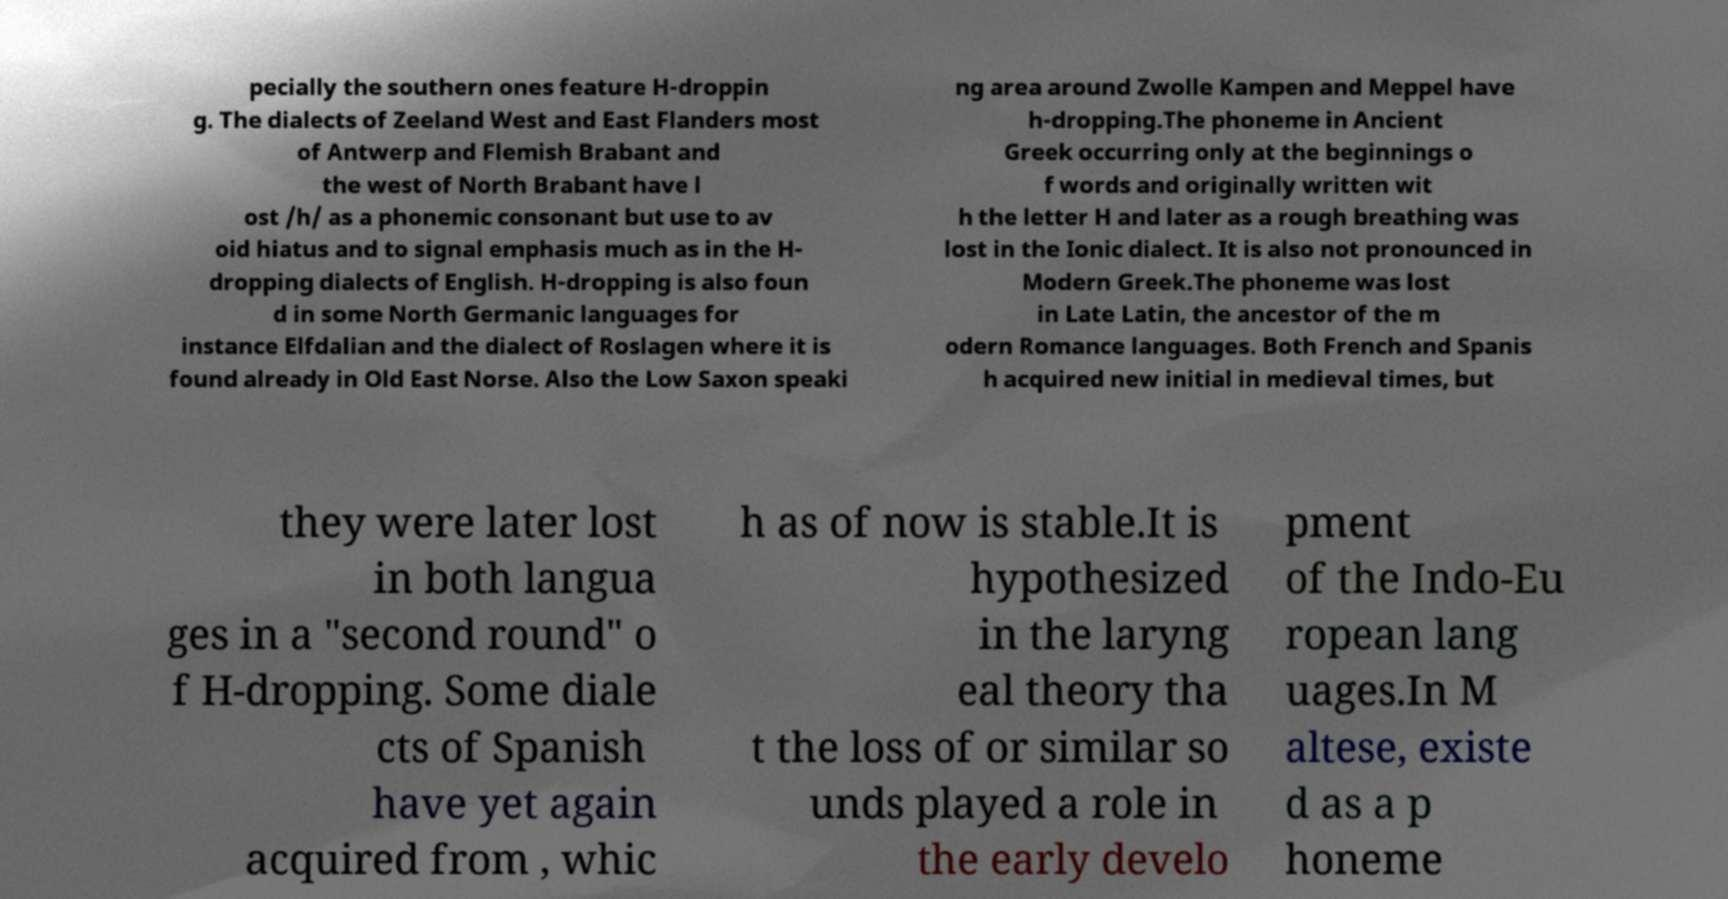For documentation purposes, I need the text within this image transcribed. Could you provide that? pecially the southern ones feature H-droppin g. The dialects of Zeeland West and East Flanders most of Antwerp and Flemish Brabant and the west of North Brabant have l ost /h/ as a phonemic consonant but use to av oid hiatus and to signal emphasis much as in the H- dropping dialects of English. H-dropping is also foun d in some North Germanic languages for instance Elfdalian and the dialect of Roslagen where it is found already in Old East Norse. Also the Low Saxon speaki ng area around Zwolle Kampen and Meppel have h-dropping.The phoneme in Ancient Greek occurring only at the beginnings o f words and originally written wit h the letter H and later as a rough breathing was lost in the Ionic dialect. It is also not pronounced in Modern Greek.The phoneme was lost in Late Latin, the ancestor of the m odern Romance languages. Both French and Spanis h acquired new initial in medieval times, but they were later lost in both langua ges in a "second round" o f H-dropping. Some diale cts of Spanish have yet again acquired from , whic h as of now is stable.It is hypothesized in the laryng eal theory tha t the loss of or similar so unds played a role in the early develo pment of the Indo-Eu ropean lang uages.In M altese, existe d as a p honeme 